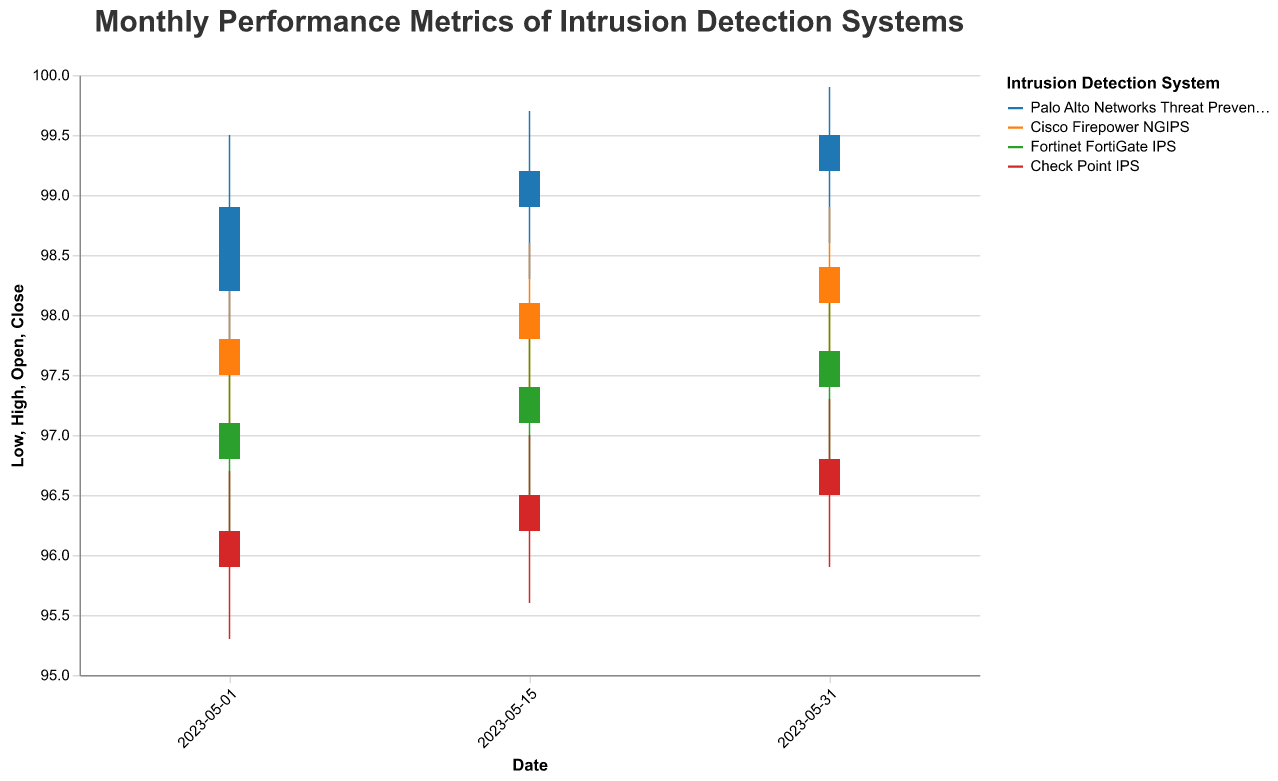How many types of Intrusion Detection Systems (IDS) are represented in the chart? The legend in the chart shows four different colors, each corresponding to a different IDS. These are "Palo Alto Networks Threat Prevention", "Cisco Firepower NGIPS", "Fortinet FortiGate IPS", and "Check Point IPS".
Answer: Four Which IDS had the highest 'Close' value at the end of May 15, 2023? On May 15, 2023, the close values are 99.2 for "Palo Alto Networks Threat Prevention", 98.1 for "Cisco Firepower NGIPS", 97.4 for "Fortinet FortiGate IPS", and 96.5 for "Check Point IPS". The highest 'Close' value is 99.2 for "Palo Alto Networks Threat Prevention".
Answer: Palo Alto Networks Threat Prevention What is the overall trend for the 'Close' values of "Cisco Firepower NGIPS" throughout the month? The 'Close' values for "Cisco Firepower NGIPS" on May 1, May 15, and May 31 are 97.8, 98.1, and 98.4, respectively. The values are increasing, indicating an upward trend.
Answer: Upward trend Which IDS had the widest range between 'High' and 'Low' values on May 01, 2023? The range between 'High' and 'Low' for each IDS on May 01 can be calculated: 
"Palo Alto Networks Threat Prevention" (99.5 - 97.8 = 1.7), 
"Cisco Firepower NGIPS" (98.3 - 96.9 = 1.4), 
"Fortinet FortiGate IPS" (97.6 - 96.2 = 1.4), 
"Check Point IPS" (96.7 - 95.3 = 1.4). 
"Palo Alto Networks Threat Prevention" has the widest range of 1.7.
Answer: Palo Alto Networks Threat Prevention What is the difference in 'Close' value between May 1 and May 31 for "Check Point IPS"? The 'Close' value for "Check Point IPS" on May 1 is 96.2, and on May 31 is 96.8. The difference is calculated as 96.8 - 96.2 = 0.6.
Answer: 0.6 Which IDS had the highest 'High' value on May 31, 2023? The 'High' values on May 31, 2023 are: 
"Palo Alto Networks Threat Prevention" 99.9, 
"Cisco Firepower NGIPS" 98.9, 
"Fortinet FortiGate IPS" 98.2, 
"Check Point IPS" 97.3. 
"Palo Alto Networks Threat Prevention" has the highest 'High' value of 99.9.
Answer: Palo Alto Networks Threat Prevention Did any IDS have a higher 'Close' value on May 15, 2023, compared to its 'Open' value on the same day? Comparing the 'Open' and 'Close' values on May 15, 2023: 
"Palo Alto Networks Threat Prevention" (Open: 98.9, Close: 99.2), 
"Cisco Firepower NGIPS" (Open: 97.8, Close: 98.1), 
"Fortinet FortiGate IPS" (Open: 97.1, Close: 97.4), 
"Check Point IPS" (Open: 96.2, Close: 96.5). 
All IDS had a higher 'Close' value compared to their 'Open' value.
Answer: Yes What is the average 'Close' value for "Fortinet FortiGate IPS" across all recorded dates? The 'Close' values for "Fortinet FortiGate IPS" are: 97.1 on May 1, 97.4 on May 15, and 97.7 on May 31. The average is calculated as (97.1 + 97.4 + 97.7) / 3 = 97.4.
Answer: 97.4 How does the performance of "Check Point IPS" compare to "Fortinet FortiGate IPS" on May 01, 2023, in terms of 'Close' values? On May 01, 2023, the 'Close' value for "Check Point IPS" is 96.2, and for "Fortinet FortiGate IPS" it is 97.1. "Fortinet FortiGate IPS" has a higher 'Close' value than "Check Point IPS".
Answer: Fortinet FortiGate IPS 